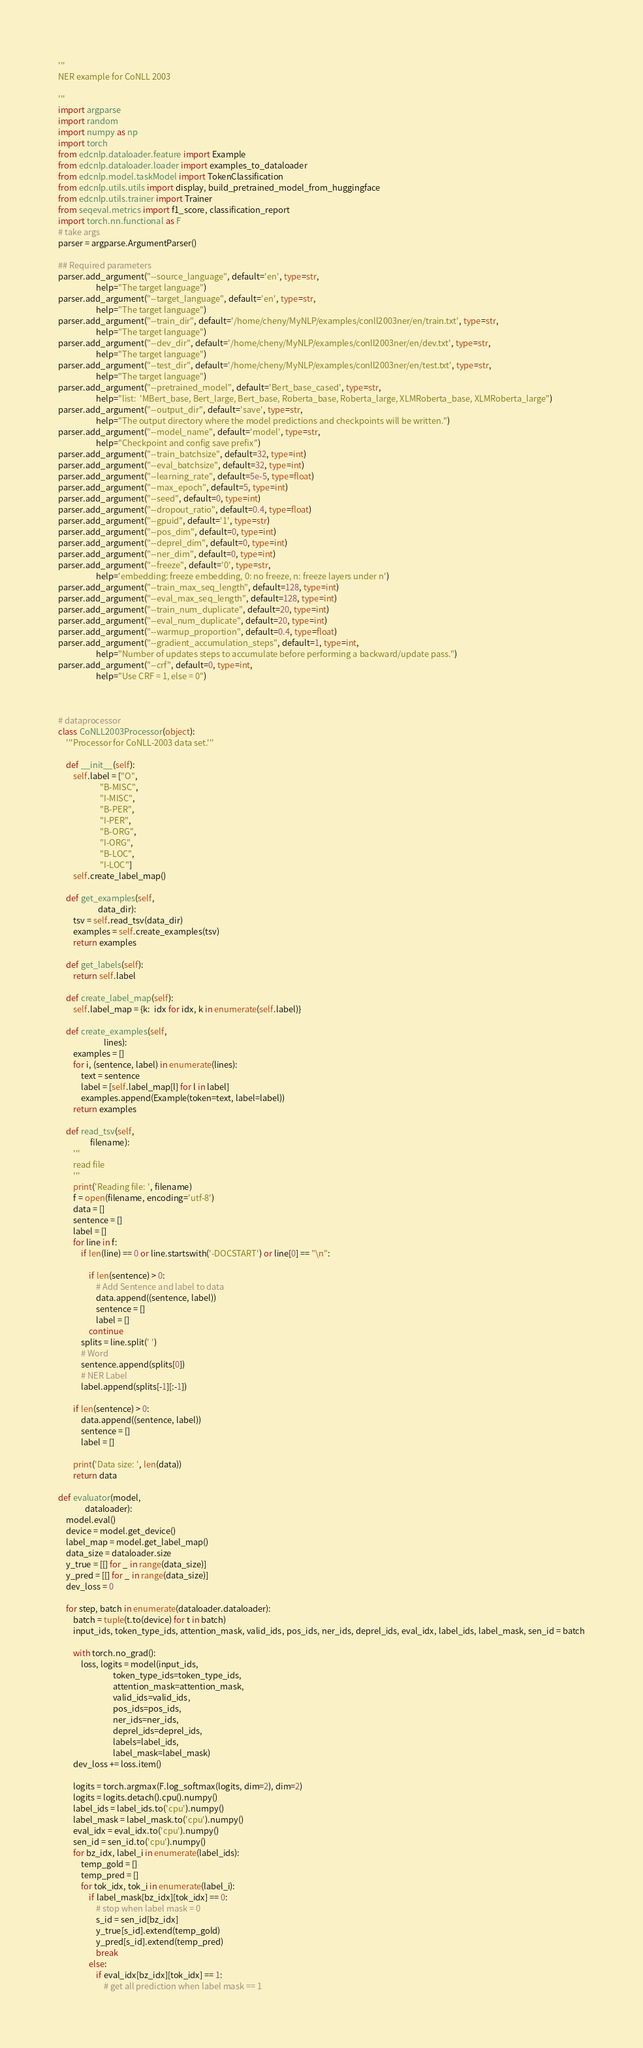Convert code to text. <code><loc_0><loc_0><loc_500><loc_500><_Python_>'''
NER example for CoNLL 2003

'''
import argparse
import random
import numpy as np
import torch
from edcnlp.dataloader.feature import Example
from edcnlp.dataloader.loader import examples_to_dataloader
from edcnlp.model.taskModel import TokenClassification
from edcnlp.utils.utils import display, build_pretrained_model_from_huggingface
from edcnlp.utils.trainer import Trainer
from seqeval.metrics import f1_score, classification_report
import torch.nn.functional as F
# take args
parser = argparse.ArgumentParser()

## Required parameters
parser.add_argument("--source_language", default='en', type=str,
                    help="The target language")
parser.add_argument("--target_language", default='en', type=str,
                    help="The target language")
parser.add_argument("--train_dir", default='/home/cheny/MyNLP/examples/conll2003ner/en/train.txt', type=str,
                    help="The target language")
parser.add_argument("--dev_dir", default='/home/cheny/MyNLP/examples/conll2003ner/en/dev.txt', type=str,
                    help="The target language")
parser.add_argument("--test_dir", default='/home/cheny/MyNLP/examples/conll2003ner/en/test.txt', type=str,
                    help="The target language")
parser.add_argument("--pretrained_model", default='Bert_base_cased', type=str,
                    help="list:  'MBert_base, Bert_large, Bert_base, Roberta_base, Roberta_large, XLMRoberta_base, XLMRoberta_large")
parser.add_argument("--output_dir", default='save', type=str,
                    help="The output directory where the model predictions and checkpoints will be written.")
parser.add_argument("--model_name", default='model', type=str,
                    help="Checkpoint and config save prefix")
parser.add_argument("--train_batchsize", default=32, type=int)
parser.add_argument("--eval_batchsize", default=32, type=int)
parser.add_argument("--learning_rate", default=5e-5, type=float)
parser.add_argument("--max_epoch", default=5, type=int)
parser.add_argument("--seed", default=0, type=int)
parser.add_argument("--dropout_ratio", default=0.4, type=float)
parser.add_argument("--gpuid", default='1', type=str)
parser.add_argument("--pos_dim", default=0, type=int)
parser.add_argument("--deprel_dim", default=0, type=int)
parser.add_argument("--ner_dim", default=0, type=int)
parser.add_argument("--freeze", default='0', type=str,
                    help='embedding: freeze embedding, 0: no freeze, n: freeze layers under n')
parser.add_argument("--train_max_seq_length", default=128, type=int)
parser.add_argument("--eval_max_seq_length", default=128, type=int)
parser.add_argument("--train_num_duplicate", default=20, type=int)
parser.add_argument("--eval_num_duplicate", default=20, type=int)
parser.add_argument("--warmup_proportion", default=0.4, type=float)
parser.add_argument("--gradient_accumulation_steps", default=1, type=int,
                    help="Number of updates steps to accumulate before performing a backward/update pass.")
parser.add_argument("--crf", default=0, type=int,
                    help="Use CRF = 1, else = 0")



# dataprocessor
class CoNLL2003Processor(object):
    '''Processor for CoNLL-2003 data set.'''

    def __init__(self):
        self.label = ["O",
                      "B-MISC",
                      "I-MISC",
                      "B-PER",
                      "I-PER",
                      "B-ORG",
                      "I-ORG",
                      "B-LOC",
                      "I-LOC"]
        self.create_label_map()

    def get_examples(self,
                     data_dir):
        tsv = self.read_tsv(data_dir)
        examples = self.create_examples(tsv)
        return examples

    def get_labels(self):
        return self.label

    def create_label_map(self):
        self.label_map = {k:  idx for idx, k in enumerate(self.label)}

    def create_examples(self,
                        lines):
        examples = []
        for i, (sentence, label) in enumerate(lines):
            text = sentence
            label = [self.label_map[l] for l in label]
            examples.append(Example(token=text, label=label))
        return examples

    def read_tsv(self,
                 filename):
        '''
        read file
        '''
        print('Reading file: ', filename)
        f = open(filename, encoding='utf-8')
        data = []
        sentence = []
        label = []
        for line in f:
            if len(line) == 0 or line.startswith('-DOCSTART') or line[0] == "\n":

                if len(sentence) > 0:
                    # Add Sentence and label to data
                    data.append((sentence, label))
                    sentence = []
                    label = []
                continue
            splits = line.split(' ')
            # Word
            sentence.append(splits[0])
            # NER Label
            label.append(splits[-1][:-1])

        if len(sentence) > 0:
            data.append((sentence, label))
            sentence = []
            label = []

        print('Data size: ', len(data))
        return data

def evaluator(model,
              dataloader):
    model.eval()
    device = model.get_device()
    label_map = model.get_label_map()
    data_size = dataloader.size
    y_true = [[] for _ in range(data_size)]
    y_pred = [[] for _ in range(data_size)]
    dev_loss = 0

    for step, batch in enumerate(dataloader.dataloader):
        batch = tuple(t.to(device) for t in batch)
        input_ids, token_type_ids, attention_mask, valid_ids, pos_ids, ner_ids, deprel_ids, eval_idx, label_ids, label_mask, sen_id = batch

        with torch.no_grad():
            loss, logits = model(input_ids,
                             token_type_ids=token_type_ids,
                             attention_mask=attention_mask,
                             valid_ids=valid_ids,
                             pos_ids=pos_ids,
                             ner_ids=ner_ids,
                             deprel_ids=deprel_ids,
                             labels=label_ids,
                             label_mask=label_mask)
        dev_loss += loss.item()

        logits = torch.argmax(F.log_softmax(logits, dim=2), dim=2)
        logits = logits.detach().cpu().numpy()
        label_ids = label_ids.to('cpu').numpy()
        label_mask = label_mask.to('cpu').numpy()
        eval_idx = eval_idx.to('cpu').numpy()
        sen_id = sen_id.to('cpu').numpy()
        for bz_idx, label_i in enumerate(label_ids):
            temp_gold = []
            temp_pred = []
            for tok_idx, tok_i in enumerate(label_i):
                if label_mask[bz_idx][tok_idx] == 0:
                    # stop when label mask = 0
                    s_id = sen_id[bz_idx]
                    y_true[s_id].extend(temp_gold)
                    y_pred[s_id].extend(temp_pred)
                    break
                else:
                    if eval_idx[bz_idx][tok_idx] == 1:
                        # get all prediction when label mask == 1</code> 